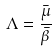<formula> <loc_0><loc_0><loc_500><loc_500>\Lambda = \frac { \bar { \mu } } { \bar { \beta } }</formula> 